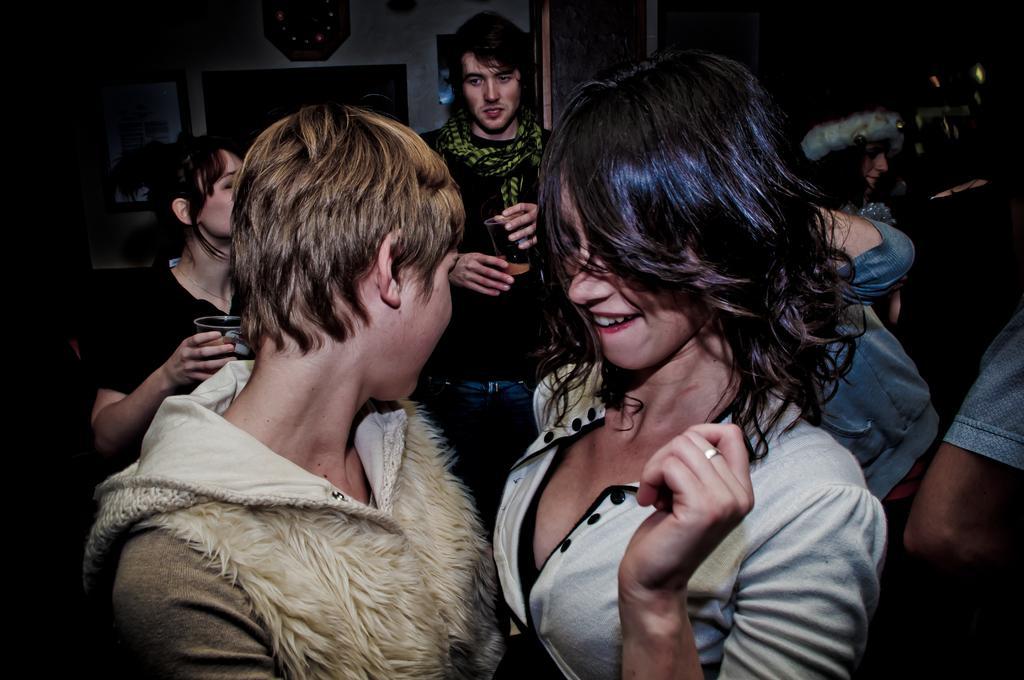Please provide a concise description of this image. In this picture I can see a woman and other person in the middle, in the background two persons are holding the wine glasses with their hands, behind them there is the wall. 